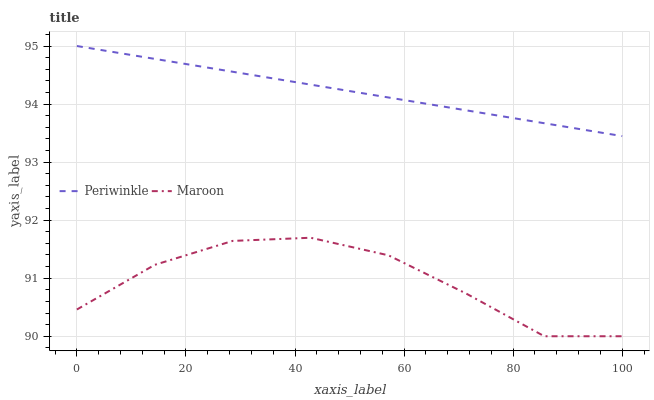Does Maroon have the minimum area under the curve?
Answer yes or no. Yes. Does Periwinkle have the maximum area under the curve?
Answer yes or no. Yes. Does Maroon have the maximum area under the curve?
Answer yes or no. No. Is Periwinkle the smoothest?
Answer yes or no. Yes. Is Maroon the roughest?
Answer yes or no. Yes. Is Maroon the smoothest?
Answer yes or no. No. Does Periwinkle have the highest value?
Answer yes or no. Yes. Does Maroon have the highest value?
Answer yes or no. No. Is Maroon less than Periwinkle?
Answer yes or no. Yes. Is Periwinkle greater than Maroon?
Answer yes or no. Yes. Does Maroon intersect Periwinkle?
Answer yes or no. No. 